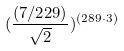Convert formula to latex. <formula><loc_0><loc_0><loc_500><loc_500>( \frac { ( 7 / 2 2 9 ) } { \sqrt { 2 } } ) ^ { ( 2 8 9 \cdot 3 ) }</formula> 